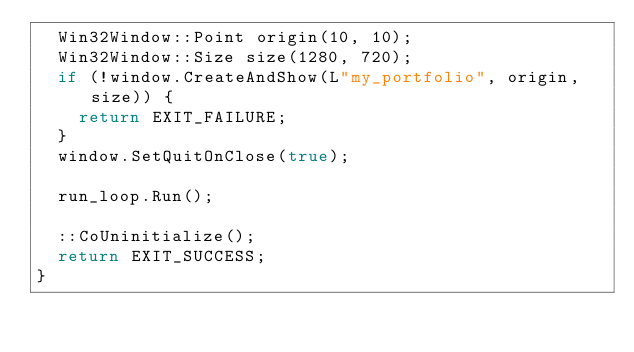Convert code to text. <code><loc_0><loc_0><loc_500><loc_500><_C++_>  Win32Window::Point origin(10, 10);
  Win32Window::Size size(1280, 720);
  if (!window.CreateAndShow(L"my_portfolio", origin, size)) {
    return EXIT_FAILURE;
  }
  window.SetQuitOnClose(true);

  run_loop.Run();

  ::CoUninitialize();
  return EXIT_SUCCESS;
}
</code> 